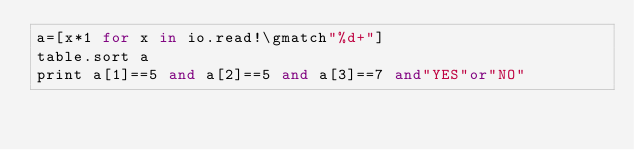<code> <loc_0><loc_0><loc_500><loc_500><_MoonScript_>a=[x*1 for x in io.read!\gmatch"%d+"]
table.sort a
print a[1]==5 and a[2]==5 and a[3]==7 and"YES"or"NO"</code> 